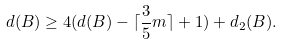Convert formula to latex. <formula><loc_0><loc_0><loc_500><loc_500>d ( B ) \geq 4 ( d ( B ) - \lceil \frac { 3 } { 5 } m \rceil + 1 ) + d _ { 2 } ( B ) .</formula> 